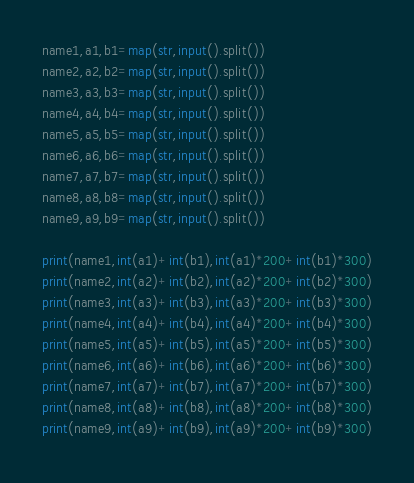<code> <loc_0><loc_0><loc_500><loc_500><_Python_>name1,a1,b1=map(str,input().split())
name2,a2,b2=map(str,input().split())
name3,a3,b3=map(str,input().split())
name4,a4,b4=map(str,input().split())
name5,a5,b5=map(str,input().split())
name6,a6,b6=map(str,input().split())
name7,a7,b7=map(str,input().split())
name8,a8,b8=map(str,input().split())
name9,a9,b9=map(str,input().split())

print(name1,int(a1)+int(b1),int(a1)*200+int(b1)*300)
print(name2,int(a2)+int(b2),int(a2)*200+int(b2)*300)
print(name3,int(a3)+int(b3),int(a3)*200+int(b3)*300)
print(name4,int(a4)+int(b4),int(a4)*200+int(b4)*300)
print(name5,int(a5)+int(b5),int(a5)*200+int(b5)*300)
print(name6,int(a6)+int(b6),int(a6)*200+int(b6)*300)
print(name7,int(a7)+int(b7),int(a7)*200+int(b7)*300)
print(name8,int(a8)+int(b8),int(a8)*200+int(b8)*300)
print(name9,int(a9)+int(b9),int(a9)*200+int(b9)*300)

</code> 